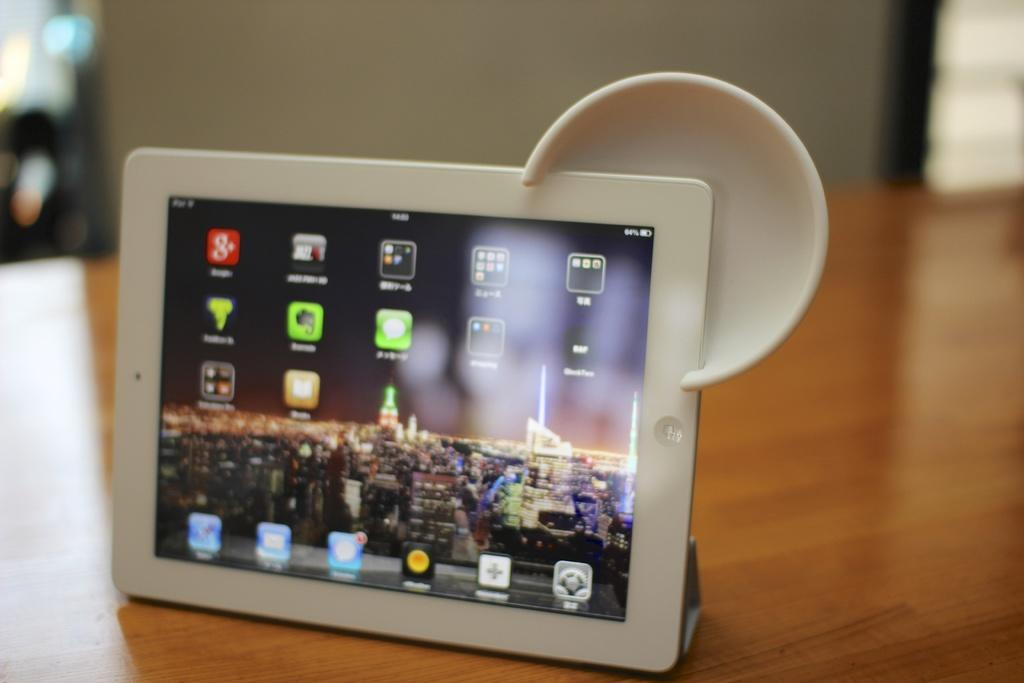What is the color of the tab in the image? The tab is white in color. Where is the tab located in the image? The tab is placed on a table. What can be seen in the background of the image? There is a wall in the background of the image. What type of skirt is hanging on the wall in the image? There is no skirt present in the image; it only features a white-colored tab on a table with a wall in the background. 